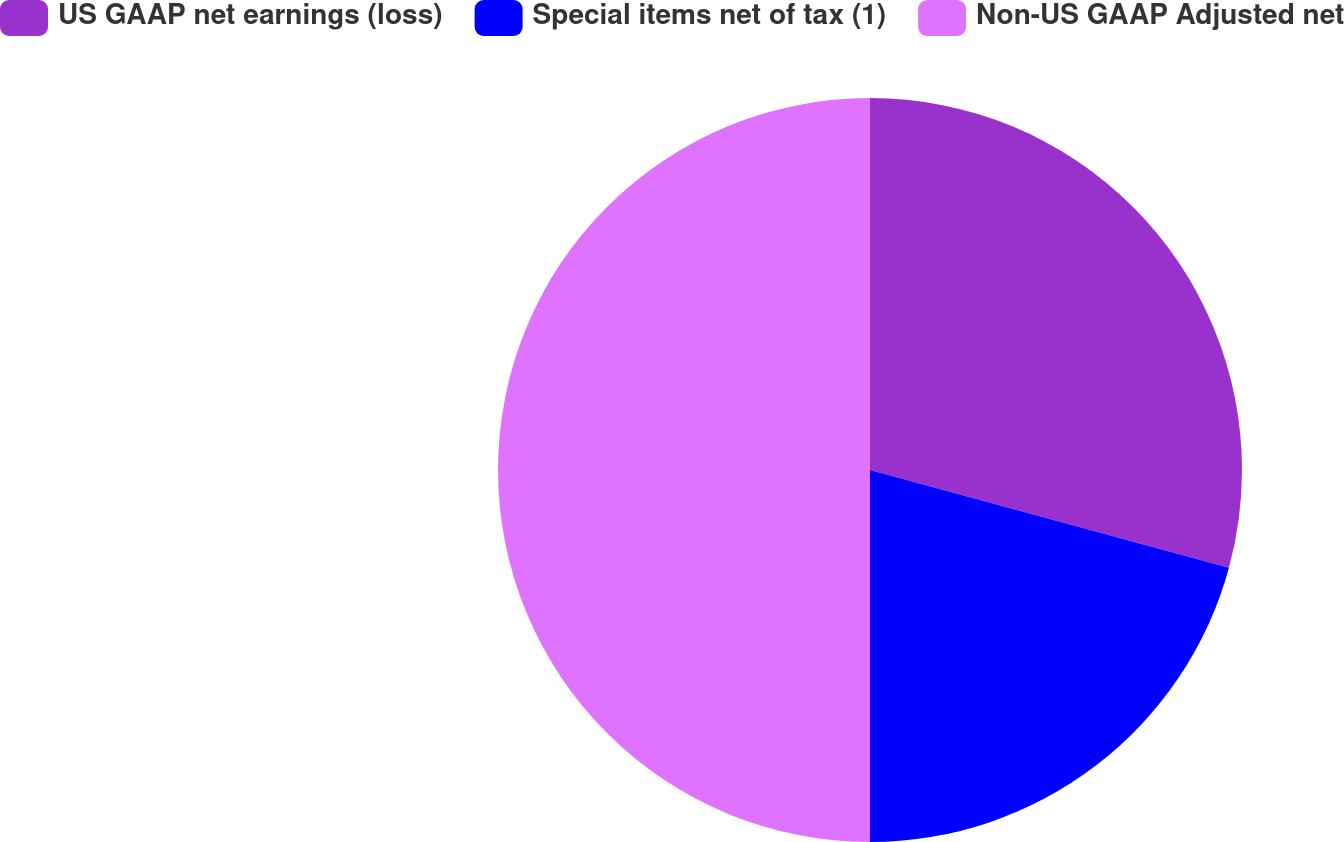Convert chart to OTSL. <chart><loc_0><loc_0><loc_500><loc_500><pie_chart><fcel>US GAAP net earnings (loss)<fcel>Special items net of tax (1)<fcel>Non-US GAAP Adjusted net<nl><fcel>29.23%<fcel>20.77%<fcel>50.0%<nl></chart> 